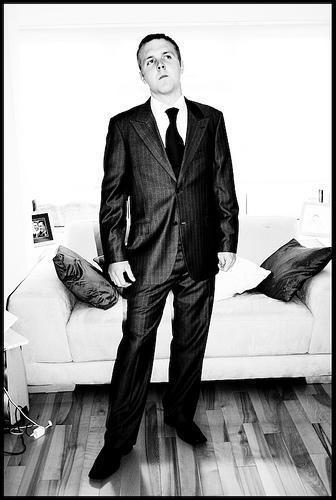How many men are there?
Give a very brief answer. 1. 